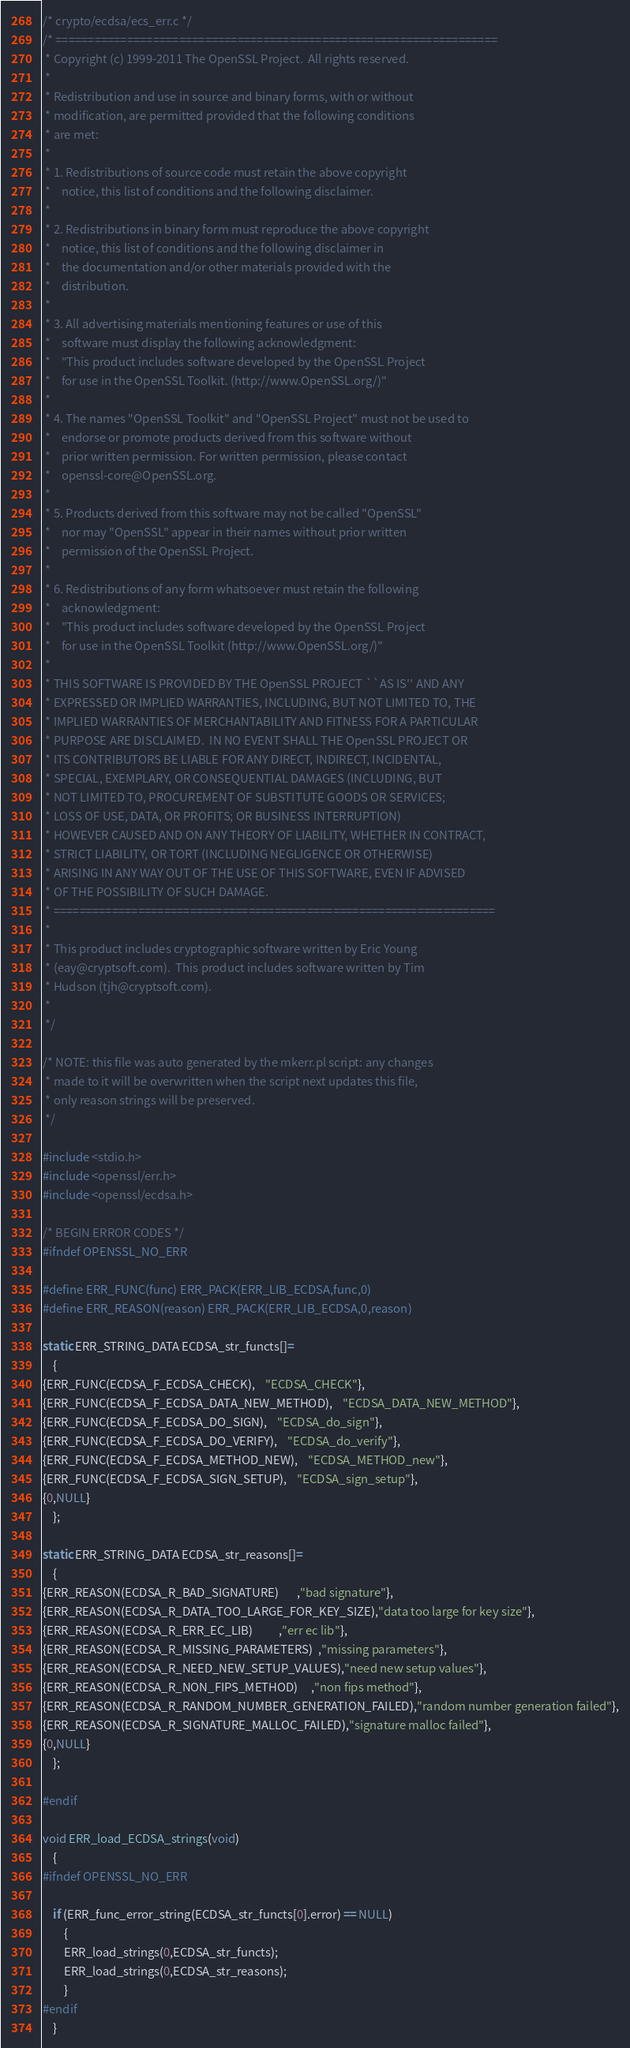Convert code to text. <code><loc_0><loc_0><loc_500><loc_500><_C_>/* crypto/ecdsa/ecs_err.c */
/* ====================================================================
 * Copyright (c) 1999-2011 The OpenSSL Project.  All rights reserved.
 *
 * Redistribution and use in source and binary forms, with or without
 * modification, are permitted provided that the following conditions
 * are met:
 *
 * 1. Redistributions of source code must retain the above copyright
 *    notice, this list of conditions and the following disclaimer. 
 *
 * 2. Redistributions in binary form must reproduce the above copyright
 *    notice, this list of conditions and the following disclaimer in
 *    the documentation and/or other materials provided with the
 *    distribution.
 *
 * 3. All advertising materials mentioning features or use of this
 *    software must display the following acknowledgment:
 *    "This product includes software developed by the OpenSSL Project
 *    for use in the OpenSSL Toolkit. (http://www.OpenSSL.org/)"
 *
 * 4. The names "OpenSSL Toolkit" and "OpenSSL Project" must not be used to
 *    endorse or promote products derived from this software without
 *    prior written permission. For written permission, please contact
 *    openssl-core@OpenSSL.org.
 *
 * 5. Products derived from this software may not be called "OpenSSL"
 *    nor may "OpenSSL" appear in their names without prior written
 *    permission of the OpenSSL Project.
 *
 * 6. Redistributions of any form whatsoever must retain the following
 *    acknowledgment:
 *    "This product includes software developed by the OpenSSL Project
 *    for use in the OpenSSL Toolkit (http://www.OpenSSL.org/)"
 *
 * THIS SOFTWARE IS PROVIDED BY THE OpenSSL PROJECT ``AS IS'' AND ANY
 * EXPRESSED OR IMPLIED WARRANTIES, INCLUDING, BUT NOT LIMITED TO, THE
 * IMPLIED WARRANTIES OF MERCHANTABILITY AND FITNESS FOR A PARTICULAR
 * PURPOSE ARE DISCLAIMED.  IN NO EVENT SHALL THE OpenSSL PROJECT OR
 * ITS CONTRIBUTORS BE LIABLE FOR ANY DIRECT, INDIRECT, INCIDENTAL,
 * SPECIAL, EXEMPLARY, OR CONSEQUENTIAL DAMAGES (INCLUDING, BUT
 * NOT LIMITED TO, PROCUREMENT OF SUBSTITUTE GOODS OR SERVICES;
 * LOSS OF USE, DATA, OR PROFITS; OR BUSINESS INTERRUPTION)
 * HOWEVER CAUSED AND ON ANY THEORY OF LIABILITY, WHETHER IN CONTRACT,
 * STRICT LIABILITY, OR TORT (INCLUDING NEGLIGENCE OR OTHERWISE)
 * ARISING IN ANY WAY OUT OF THE USE OF THIS SOFTWARE, EVEN IF ADVISED
 * OF THE POSSIBILITY OF SUCH DAMAGE.
 * ====================================================================
 *
 * This product includes cryptographic software written by Eric Young
 * (eay@cryptsoft.com).  This product includes software written by Tim
 * Hudson (tjh@cryptsoft.com).
 *
 */

/* NOTE: this file was auto generated by the mkerr.pl script: any changes
 * made to it will be overwritten when the script next updates this file,
 * only reason strings will be preserved.
 */

#include <stdio.h>
#include <openssl/err.h>
#include <openssl/ecdsa.h>

/* BEGIN ERROR CODES */
#ifndef OPENSSL_NO_ERR

#define ERR_FUNC(func) ERR_PACK(ERR_LIB_ECDSA,func,0)
#define ERR_REASON(reason) ERR_PACK(ERR_LIB_ECDSA,0,reason)

static ERR_STRING_DATA ECDSA_str_functs[]=
	{
{ERR_FUNC(ECDSA_F_ECDSA_CHECK),	"ECDSA_CHECK"},
{ERR_FUNC(ECDSA_F_ECDSA_DATA_NEW_METHOD),	"ECDSA_DATA_NEW_METHOD"},
{ERR_FUNC(ECDSA_F_ECDSA_DO_SIGN),	"ECDSA_do_sign"},
{ERR_FUNC(ECDSA_F_ECDSA_DO_VERIFY),	"ECDSA_do_verify"},
{ERR_FUNC(ECDSA_F_ECDSA_METHOD_NEW),	"ECDSA_METHOD_new"},
{ERR_FUNC(ECDSA_F_ECDSA_SIGN_SETUP),	"ECDSA_sign_setup"},
{0,NULL}
	};

static ERR_STRING_DATA ECDSA_str_reasons[]=
	{
{ERR_REASON(ECDSA_R_BAD_SIGNATURE)       ,"bad signature"},
{ERR_REASON(ECDSA_R_DATA_TOO_LARGE_FOR_KEY_SIZE),"data too large for key size"},
{ERR_REASON(ECDSA_R_ERR_EC_LIB)          ,"err ec lib"},
{ERR_REASON(ECDSA_R_MISSING_PARAMETERS)  ,"missing parameters"},
{ERR_REASON(ECDSA_R_NEED_NEW_SETUP_VALUES),"need new setup values"},
{ERR_REASON(ECDSA_R_NON_FIPS_METHOD)     ,"non fips method"},
{ERR_REASON(ECDSA_R_RANDOM_NUMBER_GENERATION_FAILED),"random number generation failed"},
{ERR_REASON(ECDSA_R_SIGNATURE_MALLOC_FAILED),"signature malloc failed"},
{0,NULL}
	};

#endif

void ERR_load_ECDSA_strings(void)
	{
#ifndef OPENSSL_NO_ERR

	if (ERR_func_error_string(ECDSA_str_functs[0].error) == NULL)
		{
		ERR_load_strings(0,ECDSA_str_functs);
		ERR_load_strings(0,ECDSA_str_reasons);
		}
#endif
	}
</code> 